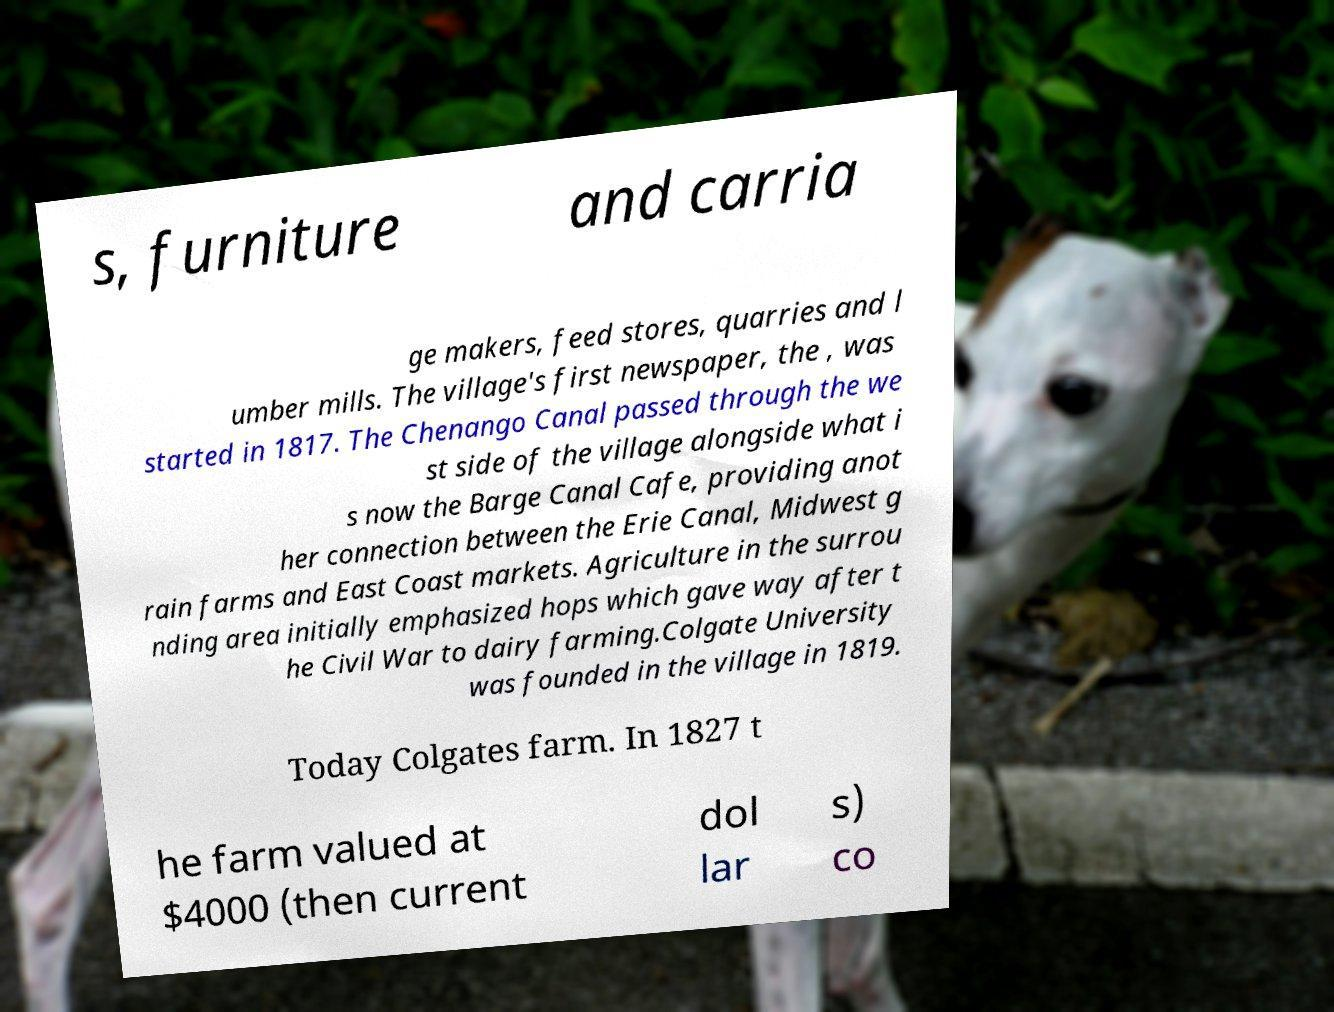Could you extract and type out the text from this image? s, furniture and carria ge makers, feed stores, quarries and l umber mills. The village's first newspaper, the , was started in 1817. The Chenango Canal passed through the we st side of the village alongside what i s now the Barge Canal Cafe, providing anot her connection between the Erie Canal, Midwest g rain farms and East Coast markets. Agriculture in the surrou nding area initially emphasized hops which gave way after t he Civil War to dairy farming.Colgate University was founded in the village in 1819. Today Colgates farm. In 1827 t he farm valued at $4000 (then current dol lar s) co 